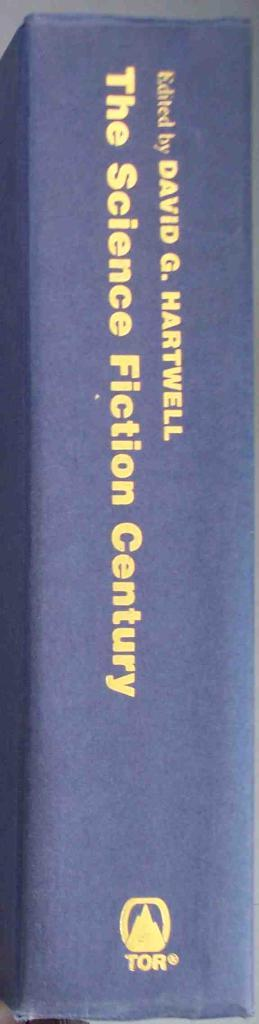<image>
Render a clear and concise summary of the photo. A blue bound Science Fiction book edited by David G. Hartwell. 